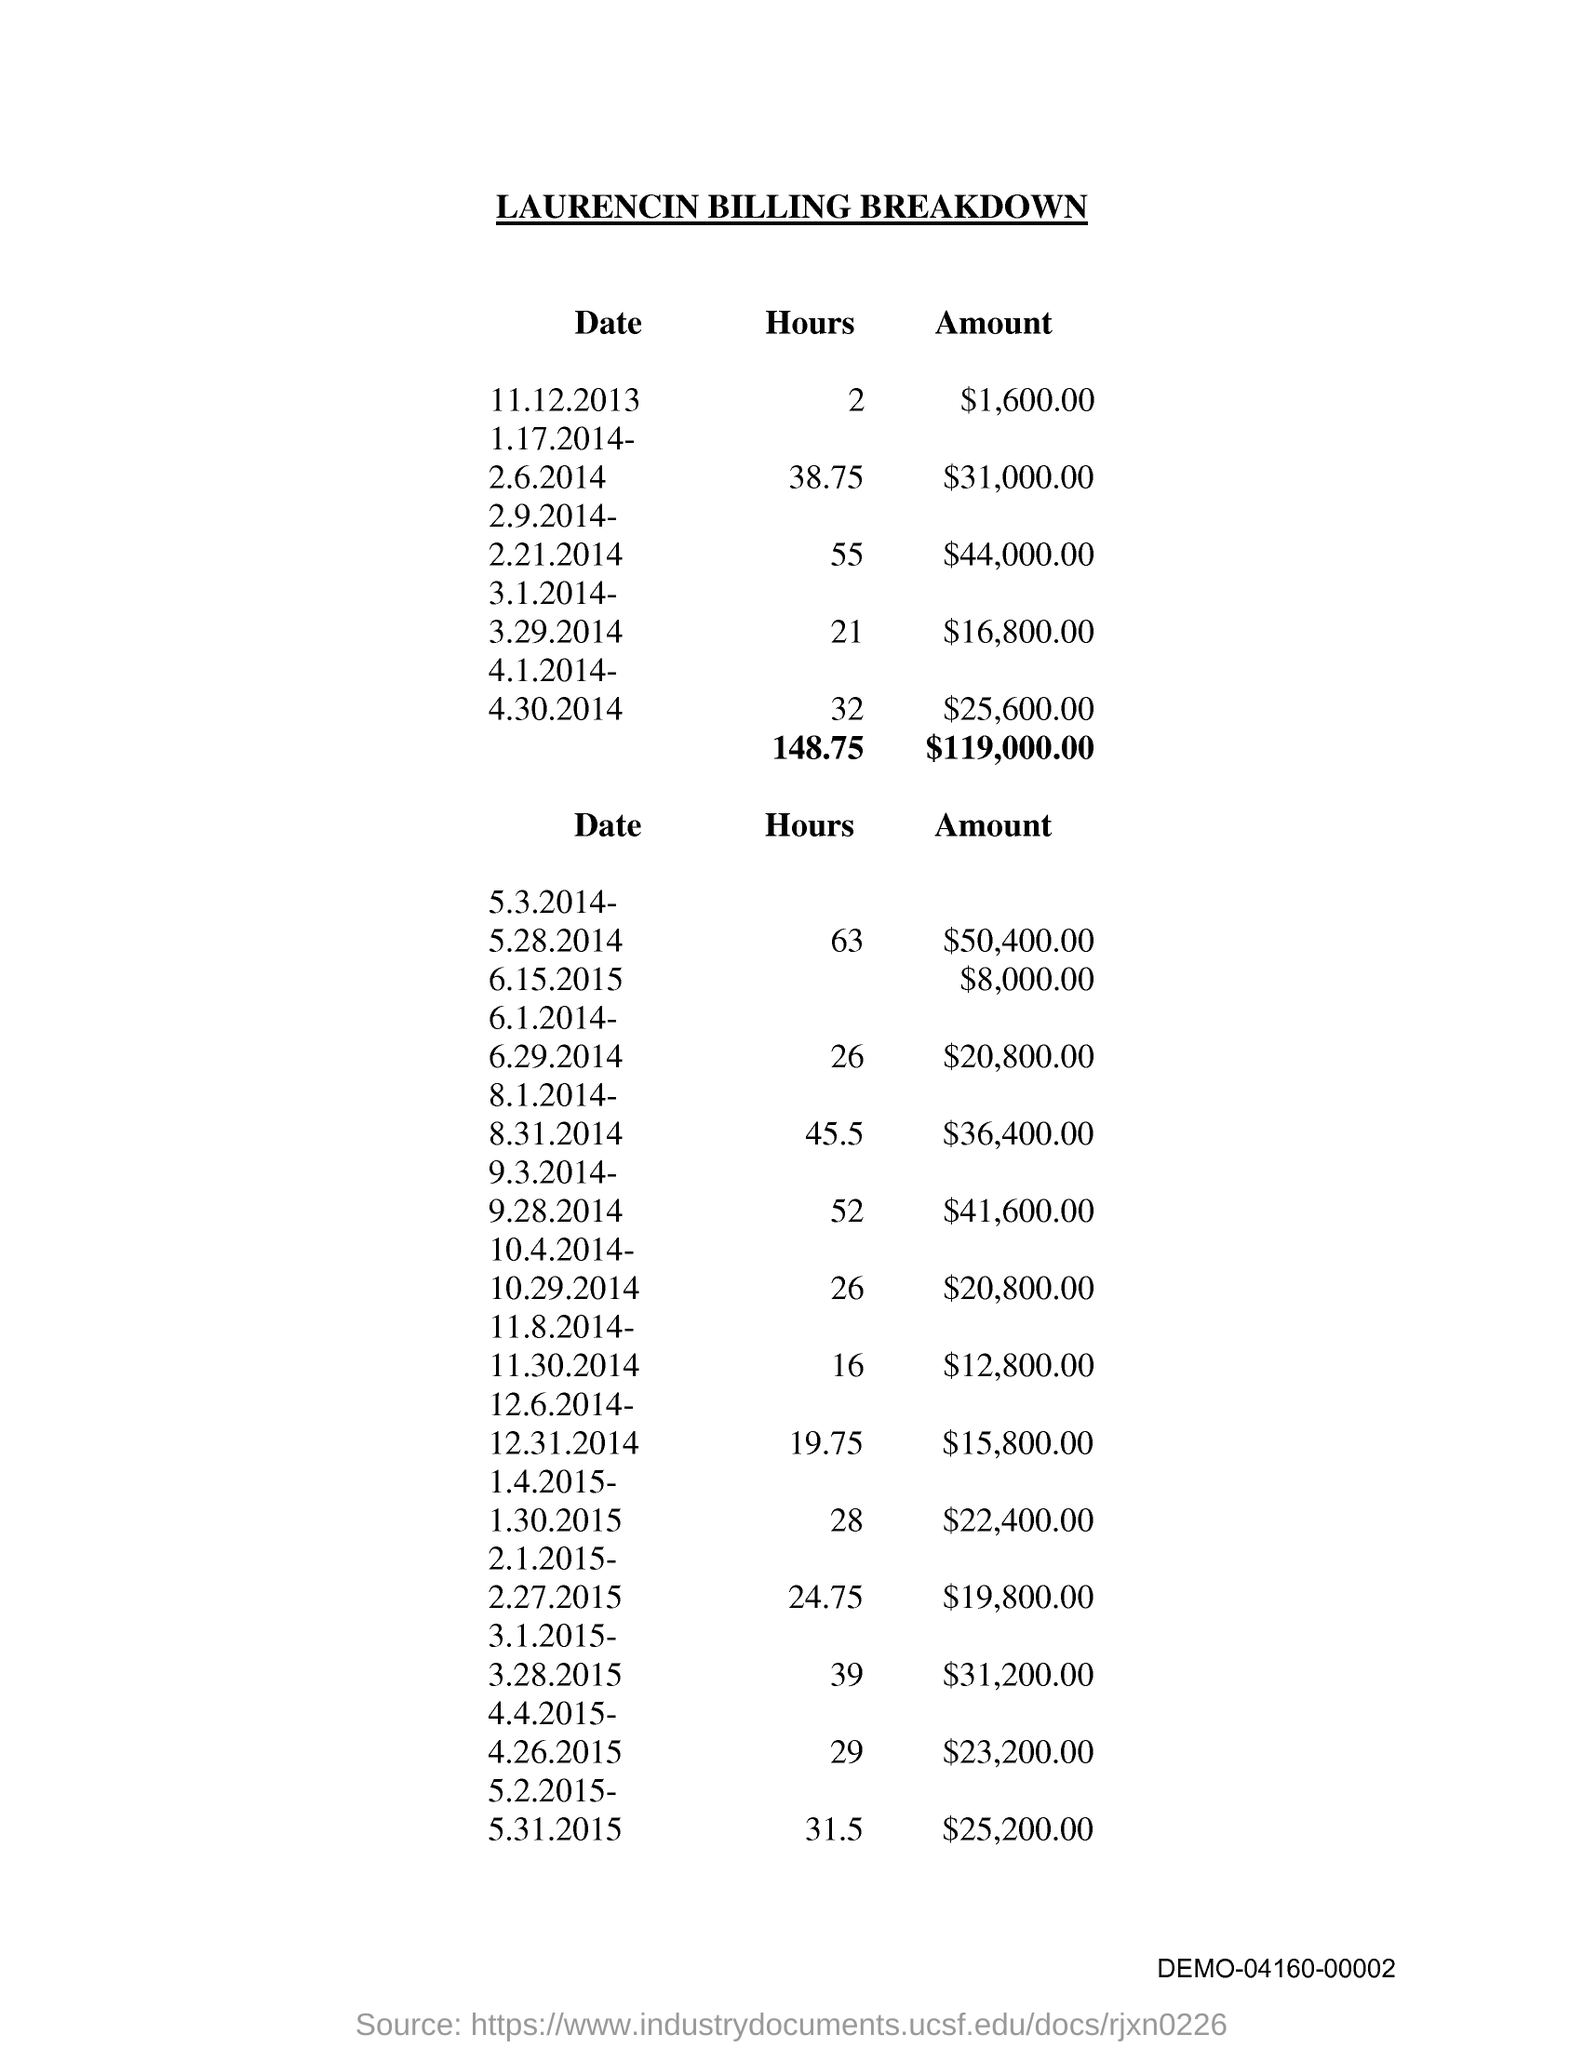Point out several critical features in this image. The document's title is 'Laurencin Billing Breakdown.' 